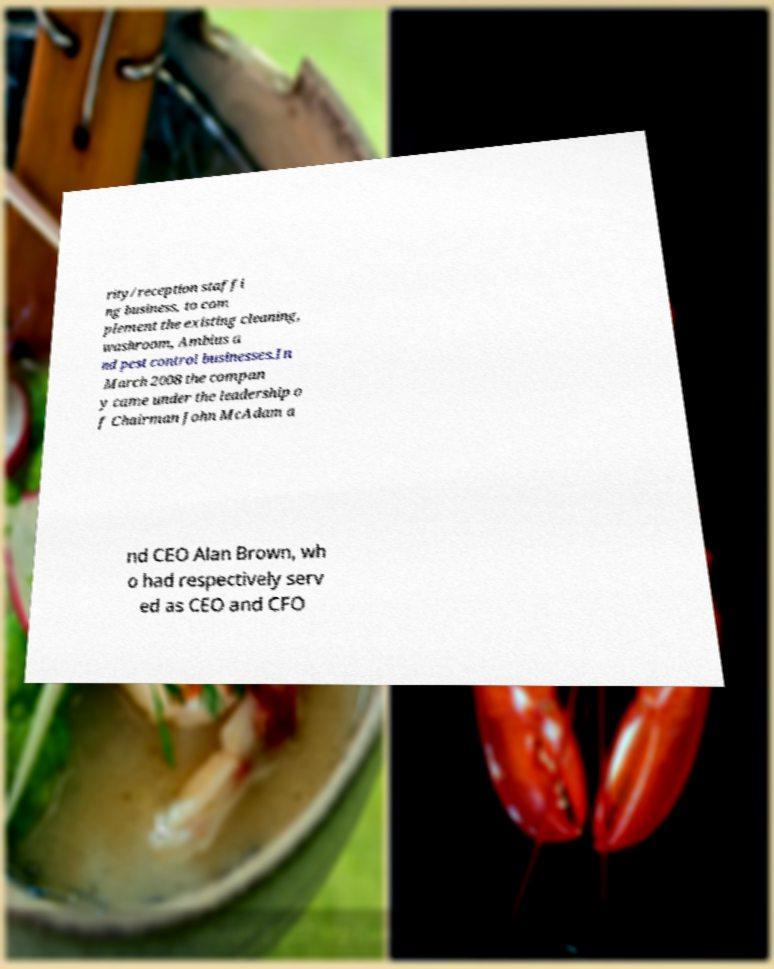For documentation purposes, I need the text within this image transcribed. Could you provide that? rity/reception staffi ng business, to com plement the existing cleaning, washroom, Ambius a nd pest control businesses.In March 2008 the compan y came under the leadership o f Chairman John McAdam a nd CEO Alan Brown, wh o had respectively serv ed as CEO and CFO 